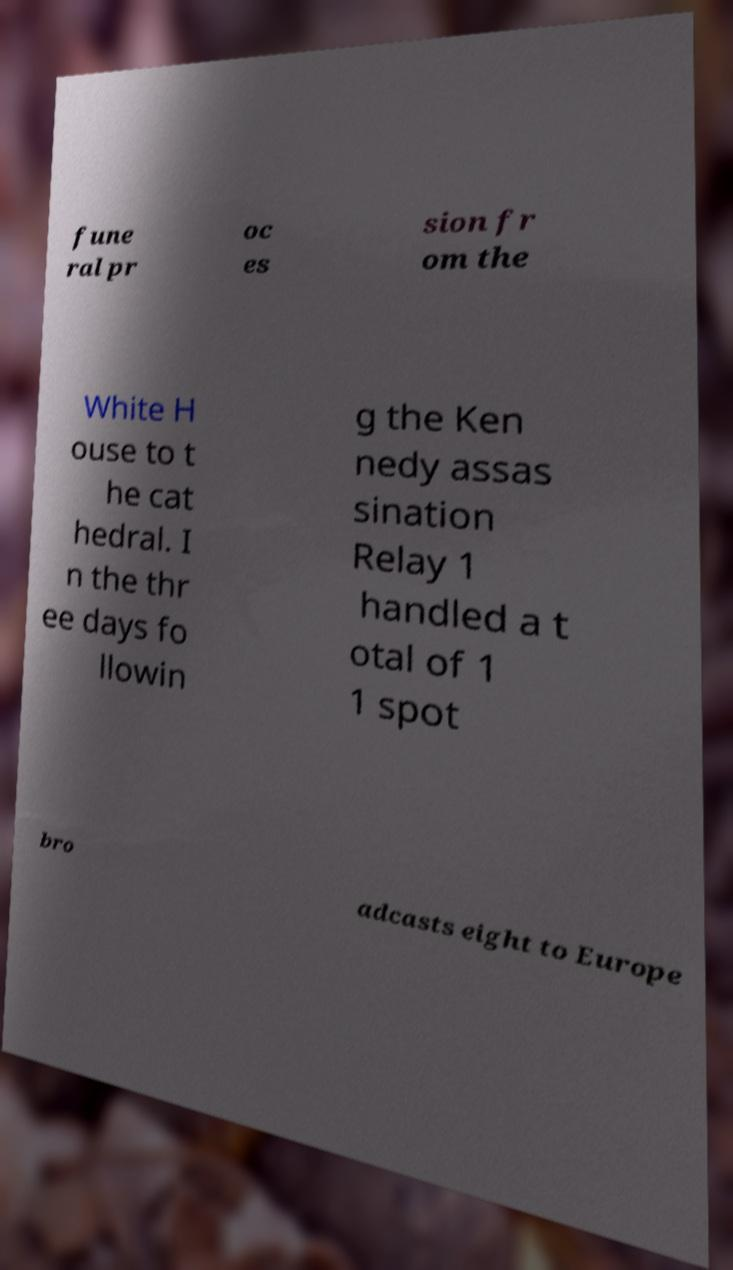Could you assist in decoding the text presented in this image and type it out clearly? fune ral pr oc es sion fr om the White H ouse to t he cat hedral. I n the thr ee days fo llowin g the Ken nedy assas sination Relay 1 handled a t otal of 1 1 spot bro adcasts eight to Europe 